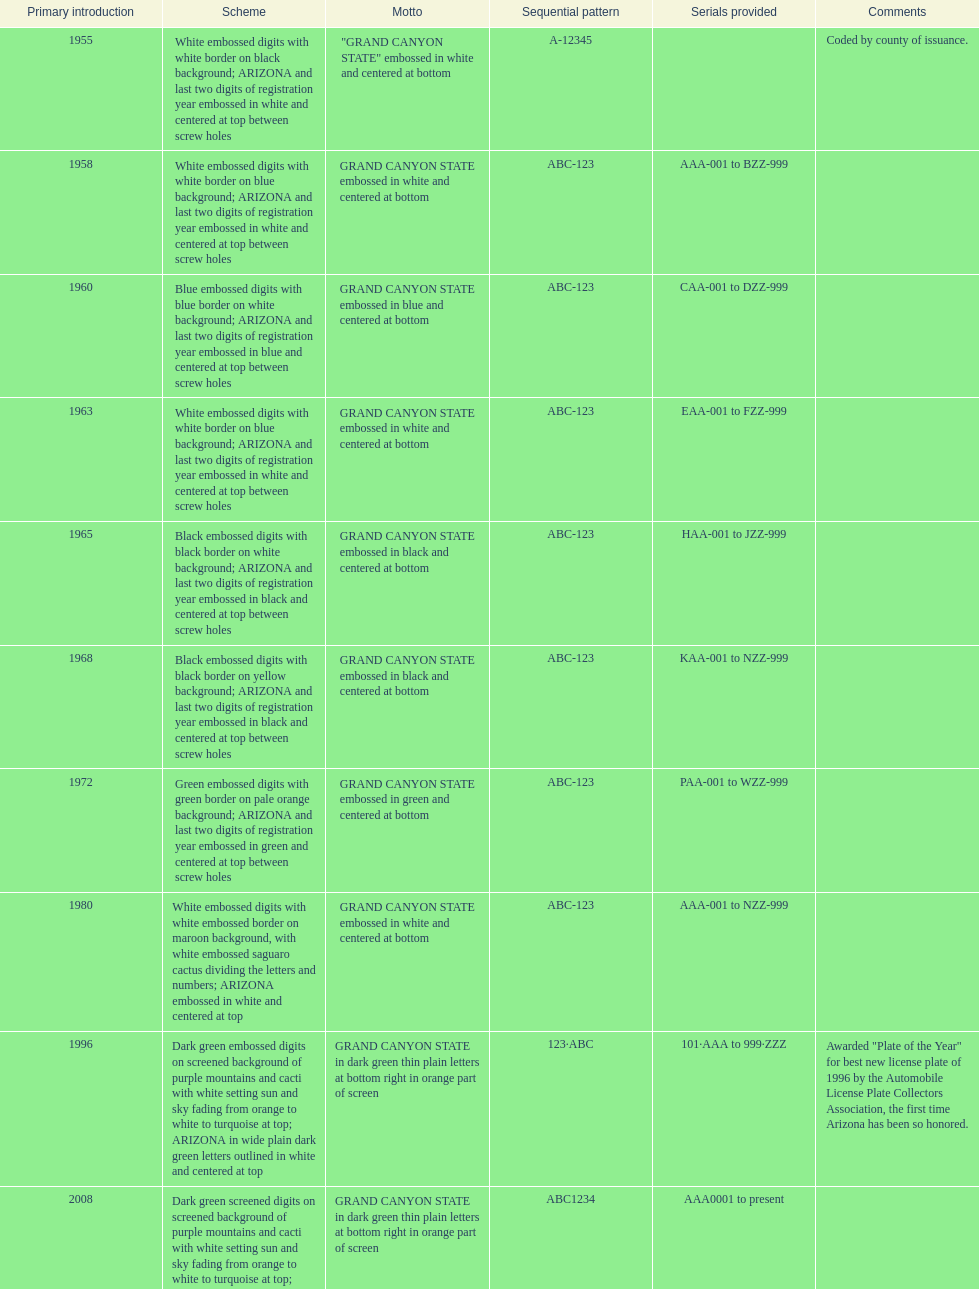Which year featured the license plate with the least characters? 1955. 